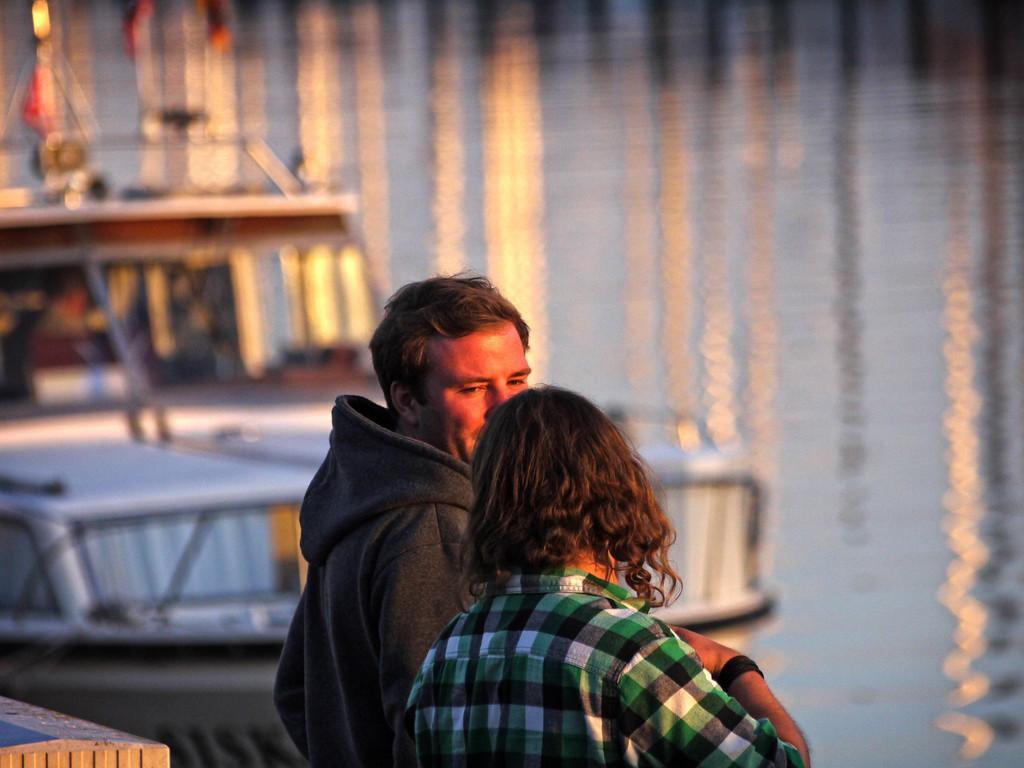How many people are in the image? There are two persons in the image. What is visible in the background of the image? There is water visible in the background of the image. What is on the water in the image? There is a boat on the water in the image. How is the background of the image depicted? The background of the image is blurred. What type of pleasure can be seen in the camp in the image? There is no camp or pleasure present in the image; it features two people and a boat on the water with a blurred background. 